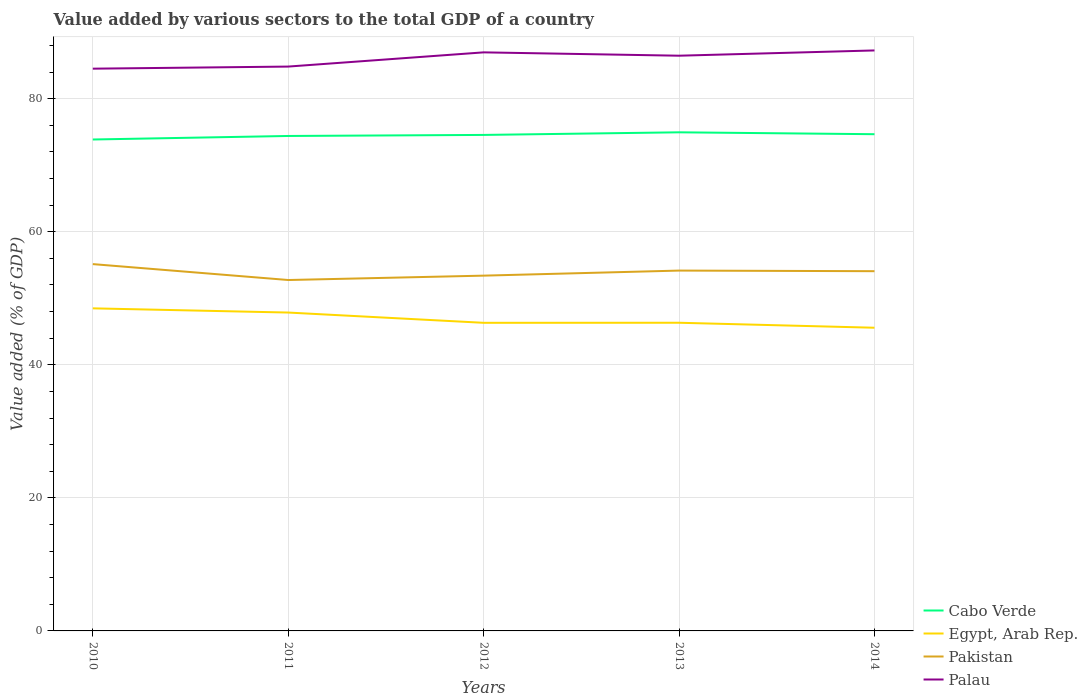How many different coloured lines are there?
Provide a short and direct response. 4. Does the line corresponding to Palau intersect with the line corresponding to Egypt, Arab Rep.?
Provide a short and direct response. No. Across all years, what is the maximum value added by various sectors to the total GDP in Palau?
Make the answer very short. 84.51. In which year was the value added by various sectors to the total GDP in Palau maximum?
Your answer should be very brief. 2010. What is the total value added by various sectors to the total GDP in Cabo Verde in the graph?
Your response must be concise. -0.16. What is the difference between the highest and the second highest value added by various sectors to the total GDP in Pakistan?
Your response must be concise. 2.39. What is the difference between the highest and the lowest value added by various sectors to the total GDP in Pakistan?
Your answer should be very brief. 3. Is the value added by various sectors to the total GDP in Palau strictly greater than the value added by various sectors to the total GDP in Pakistan over the years?
Offer a terse response. No. How many lines are there?
Ensure brevity in your answer.  4. Does the graph contain any zero values?
Provide a short and direct response. No. Where does the legend appear in the graph?
Offer a terse response. Bottom right. How many legend labels are there?
Provide a short and direct response. 4. What is the title of the graph?
Make the answer very short. Value added by various sectors to the total GDP of a country. What is the label or title of the Y-axis?
Your response must be concise. Value added (% of GDP). What is the Value added (% of GDP) of Cabo Verde in 2010?
Your response must be concise. 73.86. What is the Value added (% of GDP) in Egypt, Arab Rep. in 2010?
Provide a short and direct response. 48.48. What is the Value added (% of GDP) of Pakistan in 2010?
Your response must be concise. 55.13. What is the Value added (% of GDP) in Palau in 2010?
Offer a terse response. 84.51. What is the Value added (% of GDP) of Cabo Verde in 2011?
Provide a short and direct response. 74.39. What is the Value added (% of GDP) of Egypt, Arab Rep. in 2011?
Your response must be concise. 47.85. What is the Value added (% of GDP) in Pakistan in 2011?
Offer a very short reply. 52.74. What is the Value added (% of GDP) in Palau in 2011?
Your response must be concise. 84.82. What is the Value added (% of GDP) in Cabo Verde in 2012?
Ensure brevity in your answer.  74.55. What is the Value added (% of GDP) in Egypt, Arab Rep. in 2012?
Provide a succinct answer. 46.31. What is the Value added (% of GDP) in Pakistan in 2012?
Your answer should be compact. 53.4. What is the Value added (% of GDP) of Palau in 2012?
Provide a short and direct response. 86.96. What is the Value added (% of GDP) in Cabo Verde in 2013?
Provide a succinct answer. 74.94. What is the Value added (% of GDP) of Egypt, Arab Rep. in 2013?
Keep it short and to the point. 46.32. What is the Value added (% of GDP) of Pakistan in 2013?
Offer a very short reply. 54.16. What is the Value added (% of GDP) of Palau in 2013?
Keep it short and to the point. 86.46. What is the Value added (% of GDP) in Cabo Verde in 2014?
Your answer should be compact. 74.66. What is the Value added (% of GDP) of Egypt, Arab Rep. in 2014?
Offer a terse response. 45.57. What is the Value added (% of GDP) of Pakistan in 2014?
Provide a succinct answer. 54.07. What is the Value added (% of GDP) of Palau in 2014?
Keep it short and to the point. 87.25. Across all years, what is the maximum Value added (% of GDP) in Cabo Verde?
Offer a terse response. 74.94. Across all years, what is the maximum Value added (% of GDP) in Egypt, Arab Rep.?
Keep it short and to the point. 48.48. Across all years, what is the maximum Value added (% of GDP) in Pakistan?
Provide a short and direct response. 55.13. Across all years, what is the maximum Value added (% of GDP) of Palau?
Your answer should be compact. 87.25. Across all years, what is the minimum Value added (% of GDP) in Cabo Verde?
Your response must be concise. 73.86. Across all years, what is the minimum Value added (% of GDP) in Egypt, Arab Rep.?
Offer a very short reply. 45.57. Across all years, what is the minimum Value added (% of GDP) of Pakistan?
Keep it short and to the point. 52.74. Across all years, what is the minimum Value added (% of GDP) in Palau?
Give a very brief answer. 84.51. What is the total Value added (% of GDP) in Cabo Verde in the graph?
Make the answer very short. 372.4. What is the total Value added (% of GDP) in Egypt, Arab Rep. in the graph?
Provide a succinct answer. 234.53. What is the total Value added (% of GDP) in Pakistan in the graph?
Provide a short and direct response. 269.5. What is the total Value added (% of GDP) of Palau in the graph?
Keep it short and to the point. 429.99. What is the difference between the Value added (% of GDP) in Cabo Verde in 2010 and that in 2011?
Provide a succinct answer. -0.53. What is the difference between the Value added (% of GDP) in Egypt, Arab Rep. in 2010 and that in 2011?
Offer a terse response. 0.63. What is the difference between the Value added (% of GDP) in Pakistan in 2010 and that in 2011?
Ensure brevity in your answer.  2.39. What is the difference between the Value added (% of GDP) of Palau in 2010 and that in 2011?
Keep it short and to the point. -0.32. What is the difference between the Value added (% of GDP) in Cabo Verde in 2010 and that in 2012?
Offer a very short reply. -0.69. What is the difference between the Value added (% of GDP) in Egypt, Arab Rep. in 2010 and that in 2012?
Make the answer very short. 2.17. What is the difference between the Value added (% of GDP) of Pakistan in 2010 and that in 2012?
Provide a short and direct response. 1.73. What is the difference between the Value added (% of GDP) in Palau in 2010 and that in 2012?
Provide a succinct answer. -2.45. What is the difference between the Value added (% of GDP) in Cabo Verde in 2010 and that in 2013?
Provide a succinct answer. -1.08. What is the difference between the Value added (% of GDP) in Egypt, Arab Rep. in 2010 and that in 2013?
Provide a succinct answer. 2.16. What is the difference between the Value added (% of GDP) in Pakistan in 2010 and that in 2013?
Make the answer very short. 0.97. What is the difference between the Value added (% of GDP) of Palau in 2010 and that in 2013?
Provide a succinct answer. -1.95. What is the difference between the Value added (% of GDP) in Cabo Verde in 2010 and that in 2014?
Make the answer very short. -0.8. What is the difference between the Value added (% of GDP) of Egypt, Arab Rep. in 2010 and that in 2014?
Make the answer very short. 2.91. What is the difference between the Value added (% of GDP) of Pakistan in 2010 and that in 2014?
Provide a succinct answer. 1.06. What is the difference between the Value added (% of GDP) of Palau in 2010 and that in 2014?
Keep it short and to the point. -2.74. What is the difference between the Value added (% of GDP) of Cabo Verde in 2011 and that in 2012?
Give a very brief answer. -0.16. What is the difference between the Value added (% of GDP) in Egypt, Arab Rep. in 2011 and that in 2012?
Offer a terse response. 1.54. What is the difference between the Value added (% of GDP) in Pakistan in 2011 and that in 2012?
Keep it short and to the point. -0.66. What is the difference between the Value added (% of GDP) of Palau in 2011 and that in 2012?
Your answer should be compact. -2.14. What is the difference between the Value added (% of GDP) in Cabo Verde in 2011 and that in 2013?
Provide a succinct answer. -0.55. What is the difference between the Value added (% of GDP) of Egypt, Arab Rep. in 2011 and that in 2013?
Your answer should be compact. 1.53. What is the difference between the Value added (% of GDP) of Pakistan in 2011 and that in 2013?
Give a very brief answer. -1.42. What is the difference between the Value added (% of GDP) in Palau in 2011 and that in 2013?
Make the answer very short. -1.63. What is the difference between the Value added (% of GDP) in Cabo Verde in 2011 and that in 2014?
Provide a succinct answer. -0.26. What is the difference between the Value added (% of GDP) in Egypt, Arab Rep. in 2011 and that in 2014?
Make the answer very short. 2.28. What is the difference between the Value added (% of GDP) of Pakistan in 2011 and that in 2014?
Give a very brief answer. -1.33. What is the difference between the Value added (% of GDP) of Palau in 2011 and that in 2014?
Give a very brief answer. -2.42. What is the difference between the Value added (% of GDP) in Cabo Verde in 2012 and that in 2013?
Ensure brevity in your answer.  -0.39. What is the difference between the Value added (% of GDP) of Egypt, Arab Rep. in 2012 and that in 2013?
Offer a terse response. -0.01. What is the difference between the Value added (% of GDP) of Pakistan in 2012 and that in 2013?
Your response must be concise. -0.76. What is the difference between the Value added (% of GDP) of Palau in 2012 and that in 2013?
Your answer should be very brief. 0.5. What is the difference between the Value added (% of GDP) in Cabo Verde in 2012 and that in 2014?
Your answer should be very brief. -0.11. What is the difference between the Value added (% of GDP) in Egypt, Arab Rep. in 2012 and that in 2014?
Your answer should be very brief. 0.74. What is the difference between the Value added (% of GDP) in Pakistan in 2012 and that in 2014?
Offer a very short reply. -0.67. What is the difference between the Value added (% of GDP) of Palau in 2012 and that in 2014?
Your response must be concise. -0.29. What is the difference between the Value added (% of GDP) in Cabo Verde in 2013 and that in 2014?
Offer a terse response. 0.29. What is the difference between the Value added (% of GDP) in Egypt, Arab Rep. in 2013 and that in 2014?
Provide a succinct answer. 0.75. What is the difference between the Value added (% of GDP) in Pakistan in 2013 and that in 2014?
Ensure brevity in your answer.  0.09. What is the difference between the Value added (% of GDP) in Palau in 2013 and that in 2014?
Ensure brevity in your answer.  -0.79. What is the difference between the Value added (% of GDP) of Cabo Verde in 2010 and the Value added (% of GDP) of Egypt, Arab Rep. in 2011?
Offer a terse response. 26.01. What is the difference between the Value added (% of GDP) in Cabo Verde in 2010 and the Value added (% of GDP) in Pakistan in 2011?
Provide a succinct answer. 21.12. What is the difference between the Value added (% of GDP) of Cabo Verde in 2010 and the Value added (% of GDP) of Palau in 2011?
Keep it short and to the point. -10.96. What is the difference between the Value added (% of GDP) of Egypt, Arab Rep. in 2010 and the Value added (% of GDP) of Pakistan in 2011?
Offer a terse response. -4.26. What is the difference between the Value added (% of GDP) of Egypt, Arab Rep. in 2010 and the Value added (% of GDP) of Palau in 2011?
Give a very brief answer. -36.34. What is the difference between the Value added (% of GDP) of Pakistan in 2010 and the Value added (% of GDP) of Palau in 2011?
Your answer should be very brief. -29.69. What is the difference between the Value added (% of GDP) of Cabo Verde in 2010 and the Value added (% of GDP) of Egypt, Arab Rep. in 2012?
Your answer should be very brief. 27.55. What is the difference between the Value added (% of GDP) in Cabo Verde in 2010 and the Value added (% of GDP) in Pakistan in 2012?
Ensure brevity in your answer.  20.46. What is the difference between the Value added (% of GDP) of Cabo Verde in 2010 and the Value added (% of GDP) of Palau in 2012?
Keep it short and to the point. -13.1. What is the difference between the Value added (% of GDP) of Egypt, Arab Rep. in 2010 and the Value added (% of GDP) of Pakistan in 2012?
Offer a very short reply. -4.92. What is the difference between the Value added (% of GDP) in Egypt, Arab Rep. in 2010 and the Value added (% of GDP) in Palau in 2012?
Offer a terse response. -38.48. What is the difference between the Value added (% of GDP) of Pakistan in 2010 and the Value added (% of GDP) of Palau in 2012?
Give a very brief answer. -31.83. What is the difference between the Value added (% of GDP) of Cabo Verde in 2010 and the Value added (% of GDP) of Egypt, Arab Rep. in 2013?
Your answer should be compact. 27.54. What is the difference between the Value added (% of GDP) in Cabo Verde in 2010 and the Value added (% of GDP) in Pakistan in 2013?
Offer a very short reply. 19.7. What is the difference between the Value added (% of GDP) of Cabo Verde in 2010 and the Value added (% of GDP) of Palau in 2013?
Offer a terse response. -12.6. What is the difference between the Value added (% of GDP) of Egypt, Arab Rep. in 2010 and the Value added (% of GDP) of Pakistan in 2013?
Your response must be concise. -5.68. What is the difference between the Value added (% of GDP) of Egypt, Arab Rep. in 2010 and the Value added (% of GDP) of Palau in 2013?
Your response must be concise. -37.97. What is the difference between the Value added (% of GDP) of Pakistan in 2010 and the Value added (% of GDP) of Palau in 2013?
Give a very brief answer. -31.32. What is the difference between the Value added (% of GDP) in Cabo Verde in 2010 and the Value added (% of GDP) in Egypt, Arab Rep. in 2014?
Provide a succinct answer. 28.29. What is the difference between the Value added (% of GDP) in Cabo Verde in 2010 and the Value added (% of GDP) in Pakistan in 2014?
Give a very brief answer. 19.79. What is the difference between the Value added (% of GDP) in Cabo Verde in 2010 and the Value added (% of GDP) in Palau in 2014?
Keep it short and to the point. -13.39. What is the difference between the Value added (% of GDP) of Egypt, Arab Rep. in 2010 and the Value added (% of GDP) of Pakistan in 2014?
Provide a short and direct response. -5.58. What is the difference between the Value added (% of GDP) of Egypt, Arab Rep. in 2010 and the Value added (% of GDP) of Palau in 2014?
Offer a very short reply. -38.76. What is the difference between the Value added (% of GDP) in Pakistan in 2010 and the Value added (% of GDP) in Palau in 2014?
Make the answer very short. -32.12. What is the difference between the Value added (% of GDP) in Cabo Verde in 2011 and the Value added (% of GDP) in Egypt, Arab Rep. in 2012?
Provide a succinct answer. 28.08. What is the difference between the Value added (% of GDP) in Cabo Verde in 2011 and the Value added (% of GDP) in Pakistan in 2012?
Your answer should be very brief. 20.99. What is the difference between the Value added (% of GDP) of Cabo Verde in 2011 and the Value added (% of GDP) of Palau in 2012?
Provide a succinct answer. -12.57. What is the difference between the Value added (% of GDP) in Egypt, Arab Rep. in 2011 and the Value added (% of GDP) in Pakistan in 2012?
Your response must be concise. -5.55. What is the difference between the Value added (% of GDP) in Egypt, Arab Rep. in 2011 and the Value added (% of GDP) in Palau in 2012?
Keep it short and to the point. -39.11. What is the difference between the Value added (% of GDP) in Pakistan in 2011 and the Value added (% of GDP) in Palau in 2012?
Give a very brief answer. -34.22. What is the difference between the Value added (% of GDP) of Cabo Verde in 2011 and the Value added (% of GDP) of Egypt, Arab Rep. in 2013?
Make the answer very short. 28.07. What is the difference between the Value added (% of GDP) in Cabo Verde in 2011 and the Value added (% of GDP) in Pakistan in 2013?
Offer a terse response. 20.23. What is the difference between the Value added (% of GDP) of Cabo Verde in 2011 and the Value added (% of GDP) of Palau in 2013?
Your answer should be compact. -12.06. What is the difference between the Value added (% of GDP) in Egypt, Arab Rep. in 2011 and the Value added (% of GDP) in Pakistan in 2013?
Provide a succinct answer. -6.31. What is the difference between the Value added (% of GDP) of Egypt, Arab Rep. in 2011 and the Value added (% of GDP) of Palau in 2013?
Offer a very short reply. -38.61. What is the difference between the Value added (% of GDP) in Pakistan in 2011 and the Value added (% of GDP) in Palau in 2013?
Make the answer very short. -33.71. What is the difference between the Value added (% of GDP) of Cabo Verde in 2011 and the Value added (% of GDP) of Egypt, Arab Rep. in 2014?
Your response must be concise. 28.82. What is the difference between the Value added (% of GDP) of Cabo Verde in 2011 and the Value added (% of GDP) of Pakistan in 2014?
Ensure brevity in your answer.  20.32. What is the difference between the Value added (% of GDP) in Cabo Verde in 2011 and the Value added (% of GDP) in Palau in 2014?
Offer a terse response. -12.86. What is the difference between the Value added (% of GDP) in Egypt, Arab Rep. in 2011 and the Value added (% of GDP) in Pakistan in 2014?
Keep it short and to the point. -6.22. What is the difference between the Value added (% of GDP) of Egypt, Arab Rep. in 2011 and the Value added (% of GDP) of Palau in 2014?
Offer a very short reply. -39.4. What is the difference between the Value added (% of GDP) of Pakistan in 2011 and the Value added (% of GDP) of Palau in 2014?
Offer a very short reply. -34.5. What is the difference between the Value added (% of GDP) of Cabo Verde in 2012 and the Value added (% of GDP) of Egypt, Arab Rep. in 2013?
Make the answer very short. 28.23. What is the difference between the Value added (% of GDP) in Cabo Verde in 2012 and the Value added (% of GDP) in Pakistan in 2013?
Offer a very short reply. 20.39. What is the difference between the Value added (% of GDP) in Cabo Verde in 2012 and the Value added (% of GDP) in Palau in 2013?
Make the answer very short. -11.91. What is the difference between the Value added (% of GDP) of Egypt, Arab Rep. in 2012 and the Value added (% of GDP) of Pakistan in 2013?
Your response must be concise. -7.85. What is the difference between the Value added (% of GDP) of Egypt, Arab Rep. in 2012 and the Value added (% of GDP) of Palau in 2013?
Provide a succinct answer. -40.15. What is the difference between the Value added (% of GDP) of Pakistan in 2012 and the Value added (% of GDP) of Palau in 2013?
Keep it short and to the point. -33.06. What is the difference between the Value added (% of GDP) of Cabo Verde in 2012 and the Value added (% of GDP) of Egypt, Arab Rep. in 2014?
Your response must be concise. 28.98. What is the difference between the Value added (% of GDP) of Cabo Verde in 2012 and the Value added (% of GDP) of Pakistan in 2014?
Offer a terse response. 20.48. What is the difference between the Value added (% of GDP) in Cabo Verde in 2012 and the Value added (% of GDP) in Palau in 2014?
Provide a short and direct response. -12.7. What is the difference between the Value added (% of GDP) in Egypt, Arab Rep. in 2012 and the Value added (% of GDP) in Pakistan in 2014?
Ensure brevity in your answer.  -7.76. What is the difference between the Value added (% of GDP) in Egypt, Arab Rep. in 2012 and the Value added (% of GDP) in Palau in 2014?
Keep it short and to the point. -40.94. What is the difference between the Value added (% of GDP) in Pakistan in 2012 and the Value added (% of GDP) in Palau in 2014?
Your answer should be compact. -33.85. What is the difference between the Value added (% of GDP) in Cabo Verde in 2013 and the Value added (% of GDP) in Egypt, Arab Rep. in 2014?
Your answer should be compact. 29.37. What is the difference between the Value added (% of GDP) of Cabo Verde in 2013 and the Value added (% of GDP) of Pakistan in 2014?
Keep it short and to the point. 20.87. What is the difference between the Value added (% of GDP) in Cabo Verde in 2013 and the Value added (% of GDP) in Palau in 2014?
Offer a very short reply. -12.31. What is the difference between the Value added (% of GDP) in Egypt, Arab Rep. in 2013 and the Value added (% of GDP) in Pakistan in 2014?
Provide a short and direct response. -7.75. What is the difference between the Value added (% of GDP) of Egypt, Arab Rep. in 2013 and the Value added (% of GDP) of Palau in 2014?
Offer a terse response. -40.93. What is the difference between the Value added (% of GDP) of Pakistan in 2013 and the Value added (% of GDP) of Palau in 2014?
Your response must be concise. -33.09. What is the average Value added (% of GDP) in Cabo Verde per year?
Your response must be concise. 74.48. What is the average Value added (% of GDP) of Egypt, Arab Rep. per year?
Your response must be concise. 46.91. What is the average Value added (% of GDP) of Pakistan per year?
Your answer should be compact. 53.9. What is the average Value added (% of GDP) of Palau per year?
Ensure brevity in your answer.  86. In the year 2010, what is the difference between the Value added (% of GDP) in Cabo Verde and Value added (% of GDP) in Egypt, Arab Rep.?
Make the answer very short. 25.38. In the year 2010, what is the difference between the Value added (% of GDP) of Cabo Verde and Value added (% of GDP) of Pakistan?
Provide a short and direct response. 18.73. In the year 2010, what is the difference between the Value added (% of GDP) of Cabo Verde and Value added (% of GDP) of Palau?
Provide a short and direct response. -10.65. In the year 2010, what is the difference between the Value added (% of GDP) of Egypt, Arab Rep. and Value added (% of GDP) of Pakistan?
Provide a succinct answer. -6.65. In the year 2010, what is the difference between the Value added (% of GDP) of Egypt, Arab Rep. and Value added (% of GDP) of Palau?
Give a very brief answer. -36.02. In the year 2010, what is the difference between the Value added (% of GDP) in Pakistan and Value added (% of GDP) in Palau?
Provide a succinct answer. -29.37. In the year 2011, what is the difference between the Value added (% of GDP) of Cabo Verde and Value added (% of GDP) of Egypt, Arab Rep.?
Your answer should be compact. 26.54. In the year 2011, what is the difference between the Value added (% of GDP) of Cabo Verde and Value added (% of GDP) of Pakistan?
Provide a succinct answer. 21.65. In the year 2011, what is the difference between the Value added (% of GDP) of Cabo Verde and Value added (% of GDP) of Palau?
Your response must be concise. -10.43. In the year 2011, what is the difference between the Value added (% of GDP) of Egypt, Arab Rep. and Value added (% of GDP) of Pakistan?
Ensure brevity in your answer.  -4.89. In the year 2011, what is the difference between the Value added (% of GDP) in Egypt, Arab Rep. and Value added (% of GDP) in Palau?
Your response must be concise. -36.97. In the year 2011, what is the difference between the Value added (% of GDP) of Pakistan and Value added (% of GDP) of Palau?
Ensure brevity in your answer.  -32.08. In the year 2012, what is the difference between the Value added (% of GDP) in Cabo Verde and Value added (% of GDP) in Egypt, Arab Rep.?
Your answer should be very brief. 28.24. In the year 2012, what is the difference between the Value added (% of GDP) in Cabo Verde and Value added (% of GDP) in Pakistan?
Your answer should be compact. 21.15. In the year 2012, what is the difference between the Value added (% of GDP) in Cabo Verde and Value added (% of GDP) in Palau?
Your answer should be compact. -12.41. In the year 2012, what is the difference between the Value added (% of GDP) of Egypt, Arab Rep. and Value added (% of GDP) of Pakistan?
Make the answer very short. -7.09. In the year 2012, what is the difference between the Value added (% of GDP) in Egypt, Arab Rep. and Value added (% of GDP) in Palau?
Give a very brief answer. -40.65. In the year 2012, what is the difference between the Value added (% of GDP) of Pakistan and Value added (% of GDP) of Palau?
Give a very brief answer. -33.56. In the year 2013, what is the difference between the Value added (% of GDP) in Cabo Verde and Value added (% of GDP) in Egypt, Arab Rep.?
Your answer should be very brief. 28.62. In the year 2013, what is the difference between the Value added (% of GDP) in Cabo Verde and Value added (% of GDP) in Pakistan?
Ensure brevity in your answer.  20.78. In the year 2013, what is the difference between the Value added (% of GDP) of Cabo Verde and Value added (% of GDP) of Palau?
Your answer should be compact. -11.51. In the year 2013, what is the difference between the Value added (% of GDP) in Egypt, Arab Rep. and Value added (% of GDP) in Pakistan?
Offer a very short reply. -7.84. In the year 2013, what is the difference between the Value added (% of GDP) in Egypt, Arab Rep. and Value added (% of GDP) in Palau?
Provide a succinct answer. -40.14. In the year 2013, what is the difference between the Value added (% of GDP) of Pakistan and Value added (% of GDP) of Palau?
Offer a terse response. -32.3. In the year 2014, what is the difference between the Value added (% of GDP) in Cabo Verde and Value added (% of GDP) in Egypt, Arab Rep.?
Ensure brevity in your answer.  29.09. In the year 2014, what is the difference between the Value added (% of GDP) of Cabo Verde and Value added (% of GDP) of Pakistan?
Make the answer very short. 20.59. In the year 2014, what is the difference between the Value added (% of GDP) of Cabo Verde and Value added (% of GDP) of Palau?
Your response must be concise. -12.59. In the year 2014, what is the difference between the Value added (% of GDP) of Egypt, Arab Rep. and Value added (% of GDP) of Pakistan?
Your answer should be compact. -8.5. In the year 2014, what is the difference between the Value added (% of GDP) of Egypt, Arab Rep. and Value added (% of GDP) of Palau?
Your response must be concise. -41.68. In the year 2014, what is the difference between the Value added (% of GDP) of Pakistan and Value added (% of GDP) of Palau?
Give a very brief answer. -33.18. What is the ratio of the Value added (% of GDP) in Cabo Verde in 2010 to that in 2011?
Your response must be concise. 0.99. What is the ratio of the Value added (% of GDP) of Egypt, Arab Rep. in 2010 to that in 2011?
Offer a very short reply. 1.01. What is the ratio of the Value added (% of GDP) of Pakistan in 2010 to that in 2011?
Give a very brief answer. 1.05. What is the ratio of the Value added (% of GDP) in Palau in 2010 to that in 2011?
Make the answer very short. 1. What is the ratio of the Value added (% of GDP) in Cabo Verde in 2010 to that in 2012?
Your response must be concise. 0.99. What is the ratio of the Value added (% of GDP) of Egypt, Arab Rep. in 2010 to that in 2012?
Make the answer very short. 1.05. What is the ratio of the Value added (% of GDP) in Pakistan in 2010 to that in 2012?
Your answer should be very brief. 1.03. What is the ratio of the Value added (% of GDP) in Palau in 2010 to that in 2012?
Give a very brief answer. 0.97. What is the ratio of the Value added (% of GDP) in Cabo Verde in 2010 to that in 2013?
Give a very brief answer. 0.99. What is the ratio of the Value added (% of GDP) in Egypt, Arab Rep. in 2010 to that in 2013?
Your response must be concise. 1.05. What is the ratio of the Value added (% of GDP) of Pakistan in 2010 to that in 2013?
Offer a very short reply. 1.02. What is the ratio of the Value added (% of GDP) in Palau in 2010 to that in 2013?
Provide a succinct answer. 0.98. What is the ratio of the Value added (% of GDP) in Cabo Verde in 2010 to that in 2014?
Offer a terse response. 0.99. What is the ratio of the Value added (% of GDP) in Egypt, Arab Rep. in 2010 to that in 2014?
Provide a succinct answer. 1.06. What is the ratio of the Value added (% of GDP) of Pakistan in 2010 to that in 2014?
Keep it short and to the point. 1.02. What is the ratio of the Value added (% of GDP) of Palau in 2010 to that in 2014?
Provide a short and direct response. 0.97. What is the ratio of the Value added (% of GDP) of Palau in 2011 to that in 2012?
Offer a very short reply. 0.98. What is the ratio of the Value added (% of GDP) of Cabo Verde in 2011 to that in 2013?
Provide a short and direct response. 0.99. What is the ratio of the Value added (% of GDP) of Egypt, Arab Rep. in 2011 to that in 2013?
Offer a terse response. 1.03. What is the ratio of the Value added (% of GDP) in Pakistan in 2011 to that in 2013?
Provide a succinct answer. 0.97. What is the ratio of the Value added (% of GDP) of Palau in 2011 to that in 2013?
Ensure brevity in your answer.  0.98. What is the ratio of the Value added (% of GDP) in Egypt, Arab Rep. in 2011 to that in 2014?
Offer a very short reply. 1.05. What is the ratio of the Value added (% of GDP) of Pakistan in 2011 to that in 2014?
Provide a short and direct response. 0.98. What is the ratio of the Value added (% of GDP) of Palau in 2011 to that in 2014?
Offer a very short reply. 0.97. What is the ratio of the Value added (% of GDP) of Cabo Verde in 2012 to that in 2013?
Give a very brief answer. 0.99. What is the ratio of the Value added (% of GDP) of Egypt, Arab Rep. in 2012 to that in 2013?
Your answer should be compact. 1. What is the ratio of the Value added (% of GDP) in Pakistan in 2012 to that in 2013?
Make the answer very short. 0.99. What is the ratio of the Value added (% of GDP) of Palau in 2012 to that in 2013?
Your answer should be very brief. 1.01. What is the ratio of the Value added (% of GDP) of Egypt, Arab Rep. in 2012 to that in 2014?
Provide a succinct answer. 1.02. What is the ratio of the Value added (% of GDP) of Pakistan in 2012 to that in 2014?
Your answer should be very brief. 0.99. What is the ratio of the Value added (% of GDP) of Egypt, Arab Rep. in 2013 to that in 2014?
Make the answer very short. 1.02. What is the ratio of the Value added (% of GDP) in Palau in 2013 to that in 2014?
Ensure brevity in your answer.  0.99. What is the difference between the highest and the second highest Value added (% of GDP) of Cabo Verde?
Ensure brevity in your answer.  0.29. What is the difference between the highest and the second highest Value added (% of GDP) in Egypt, Arab Rep.?
Give a very brief answer. 0.63. What is the difference between the highest and the second highest Value added (% of GDP) of Pakistan?
Offer a very short reply. 0.97. What is the difference between the highest and the second highest Value added (% of GDP) in Palau?
Ensure brevity in your answer.  0.29. What is the difference between the highest and the lowest Value added (% of GDP) in Cabo Verde?
Your answer should be very brief. 1.08. What is the difference between the highest and the lowest Value added (% of GDP) in Egypt, Arab Rep.?
Offer a terse response. 2.91. What is the difference between the highest and the lowest Value added (% of GDP) of Pakistan?
Provide a short and direct response. 2.39. What is the difference between the highest and the lowest Value added (% of GDP) in Palau?
Provide a short and direct response. 2.74. 